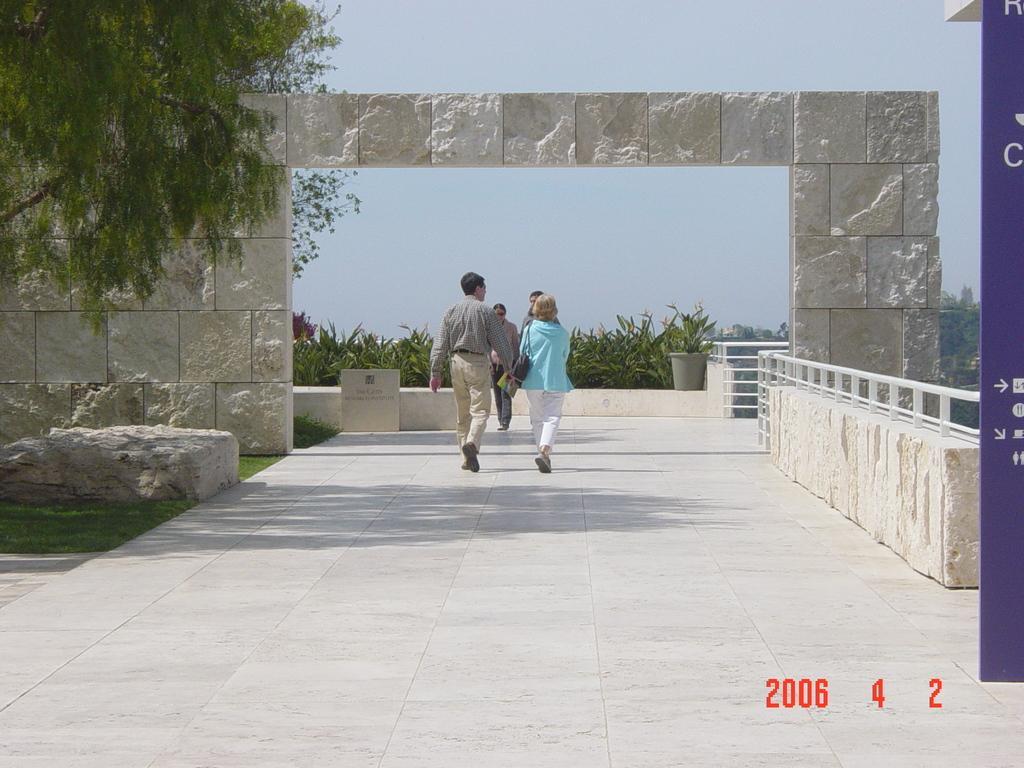Please provide a concise description of this image. At the center of the image there are people walking on the floor. On the right side of the image there is a banner. There is a railing. On the left side of the image there is grass on the surface. There is a rock. There is a rock wall. In the background of the image there is a flower pot. There is a board with some text on it. There are trees. At the top of the image there is sky. There are some numbers at the bottom of the image. 